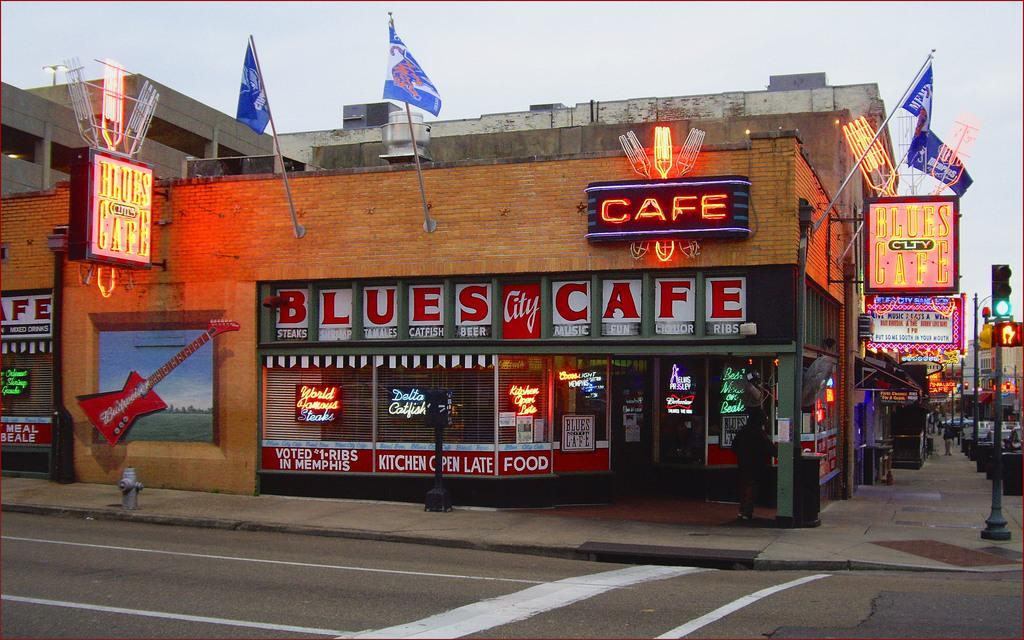What type of structure is visible in the image with lights? There is a building with lights in the image. What can be found on a pole in the image? There is a pole with traffic lights in the image. What type of lettuce can be seen growing near the traffic lights in the image? There is no lettuce present in the image; it only features a building with lights and a pole with traffic lights. 